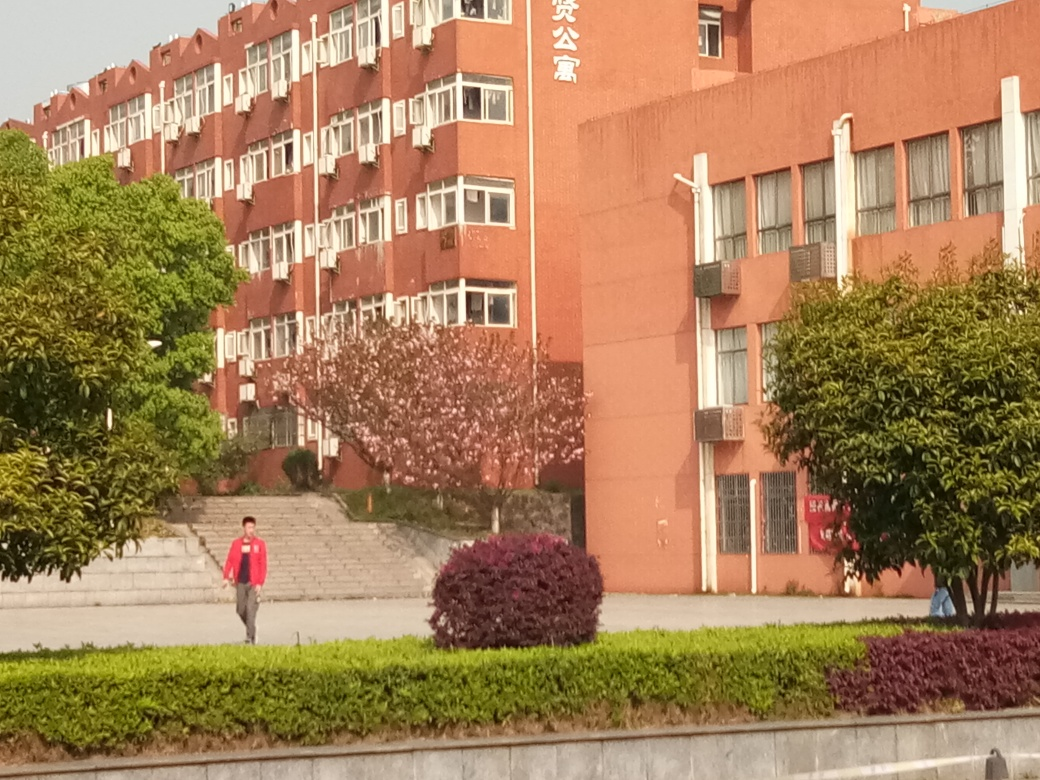What could be the significance of the building's color scheme? The building's color scheme, with its dominant red hues, could be deliberate and symbolic. Red is often associated with energy, power, and passion and is a color that stands out in urban and natural settings, giving the building a prominent visual presence. In some cultures, red is also associated with good fortune and celebration, which might contribute to the chosen color for a public institution. 